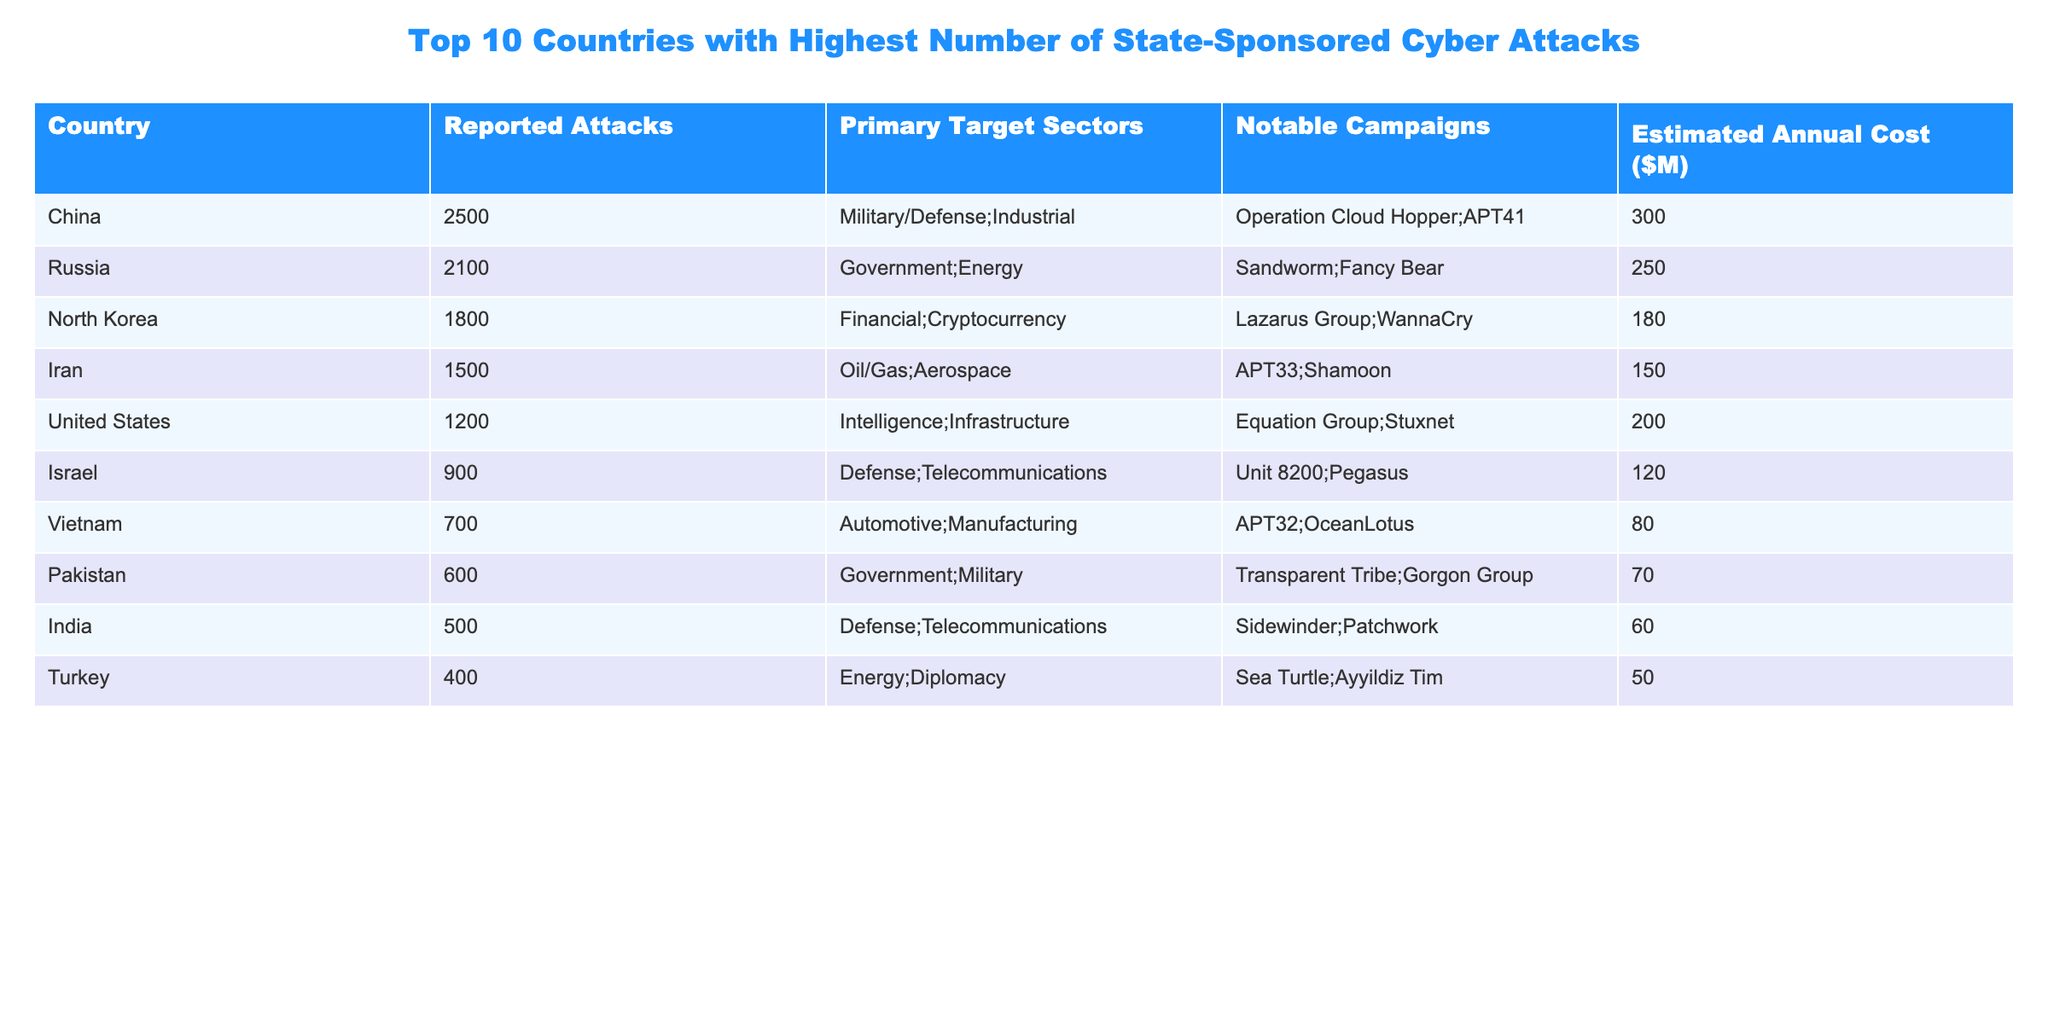What country reported the highest number of state-sponsored cyber attacks? According to the table, China has the highest number of reported attacks at 2500.
Answer: China What is the estimated annual cost of cyber attacks from Russia? The table lists the estimated annual cost of cyber attacks from Russia as $250 million.
Answer: $250 million Which country has the lowest number of reported cyber attacks? The data reveals that Turkey has the lowest number of reported attacks at 400.
Answer: Turkey What are the primary target sectors for North Korea? North Korea's primary target sectors are listed as Financial and Cryptocurrency.
Answer: Financial; Cryptocurrency How many reported attacks did the United States conduct compared to Israel? The United States conducted 1200 attacks, while Israel had 900, meaning the U.S. had 300 more attacks than Israel.
Answer: 300 more What is the average estimated annual cost of cyber attacks for the top three countries? The estimated costs for the top three countries are China ($300M), Russia ($250M), and North Korea ($180M). Adding these gives $730M, and dividing by 3 gives an average of $243.33 million.
Answer: $243.33 million Is it true that all countries listed have a primary target sector in defense? No, not all countries listed have a primary target sector in defense; for example, Vietnam focuses on Automotive and Manufacturing.
Answer: No Which country is associated with the notable campaign "WannaCry"? The table specifies that North Korea is associated with the notable campaign "WannaCry".
Answer: North Korea How many attacks were reported by Iran compared to Vietnam? Iran reported 1500 attacks while Vietnam reported 700 attacks. The difference is 800 more attacks reported by Iran.
Answer: 800 more What is the total number of reported attacks from the bottom three countries (Pakistan, India, Turkey)? The reported attacks from Pakistan, India, and Turkey are 600, 500, and 400, respectively. Adding these gives 600 + 500 + 400 = 1500 reported attacks in total.
Answer: 1500 